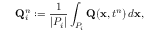Convert formula to latex. <formula><loc_0><loc_0><loc_500><loc_500>Q _ { i } ^ { n } \colon = \frac { 1 } { | P _ { i } | } \int _ { P _ { i } } Q ( x , t ^ { n } ) \, d x ,</formula> 